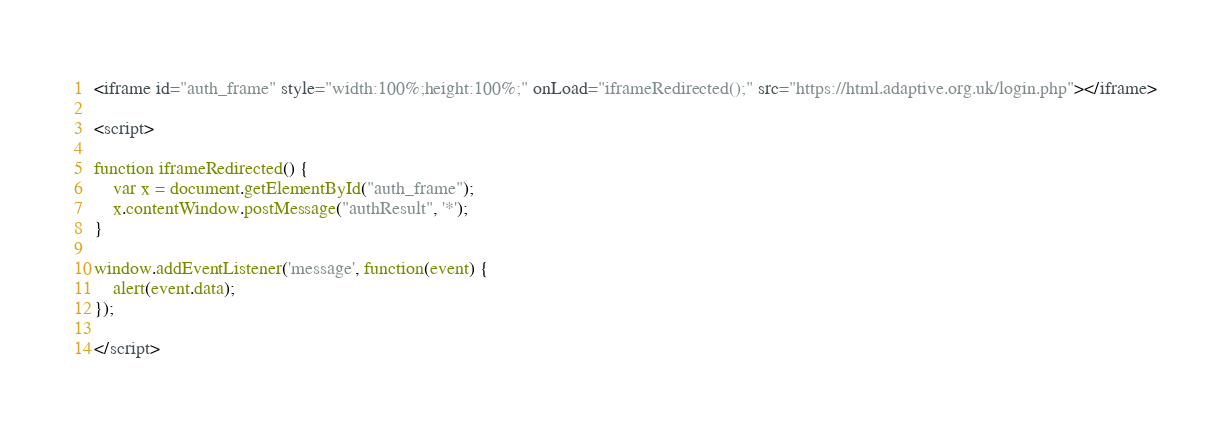Convert code to text. <code><loc_0><loc_0><loc_500><loc_500><_HTML_><iframe id="auth_frame" style="width:100%;height:100%;" onLoad="iframeRedirected();" src="https://html.adaptive.org.uk/login.php"></iframe>

<script>

function iframeRedirected() {
    var x = document.getElementById("auth_frame");
    x.contentWindow.postMessage("authResult", '*');
}

window.addEventListener('message', function(event) {
    alert(event.data);
});

</script>
</code> 